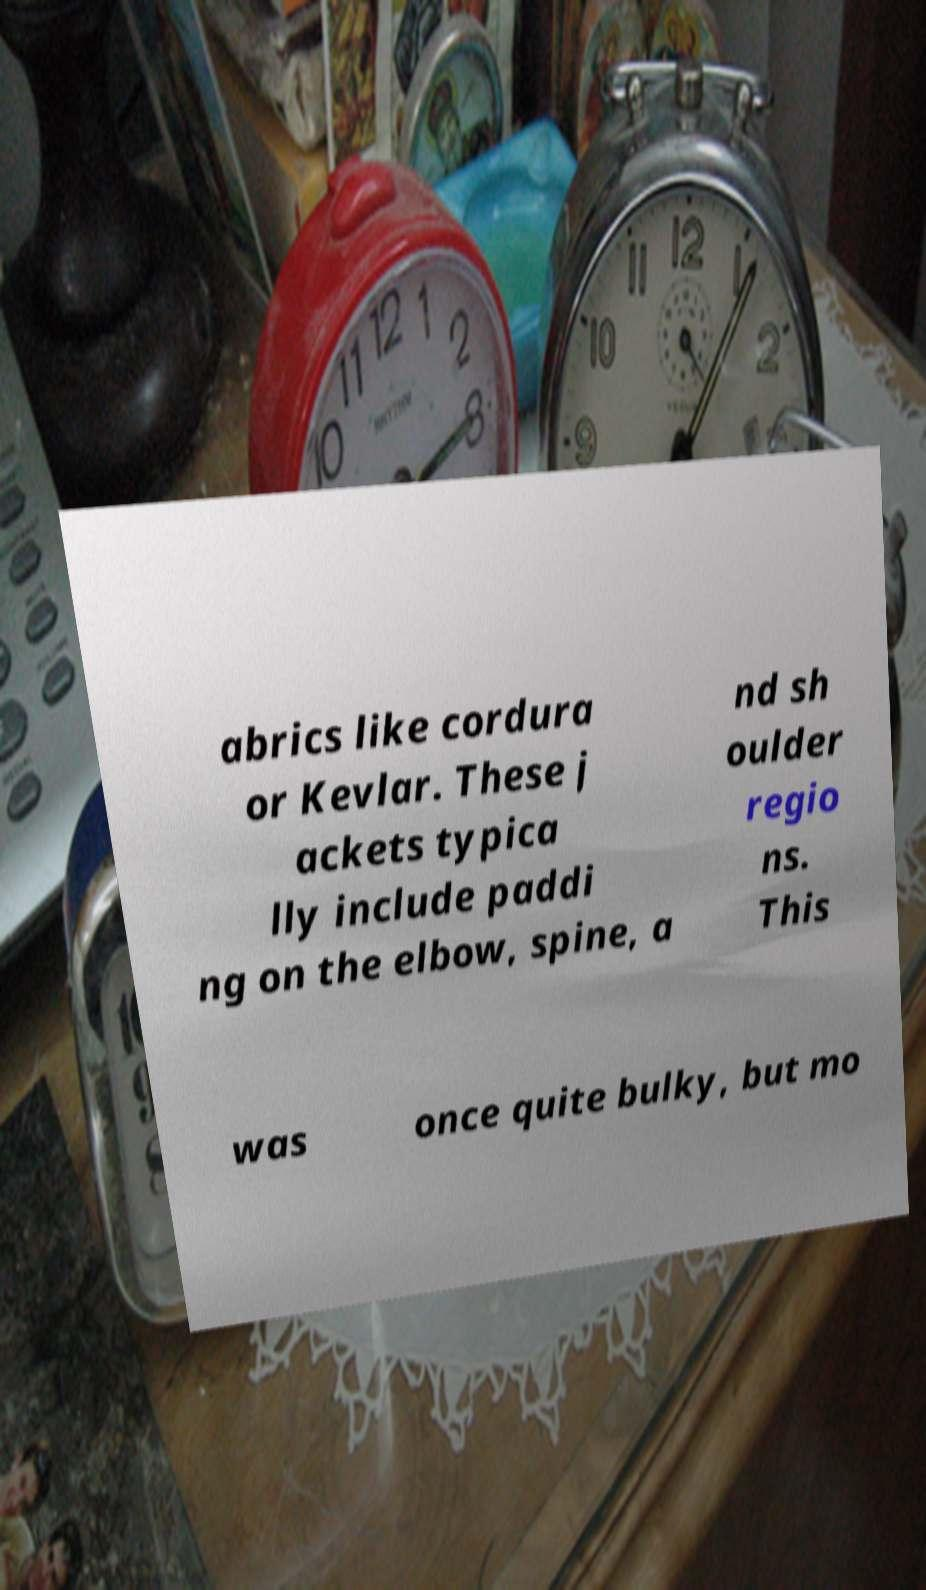There's text embedded in this image that I need extracted. Can you transcribe it verbatim? abrics like cordura or Kevlar. These j ackets typica lly include paddi ng on the elbow, spine, a nd sh oulder regio ns. This was once quite bulky, but mo 